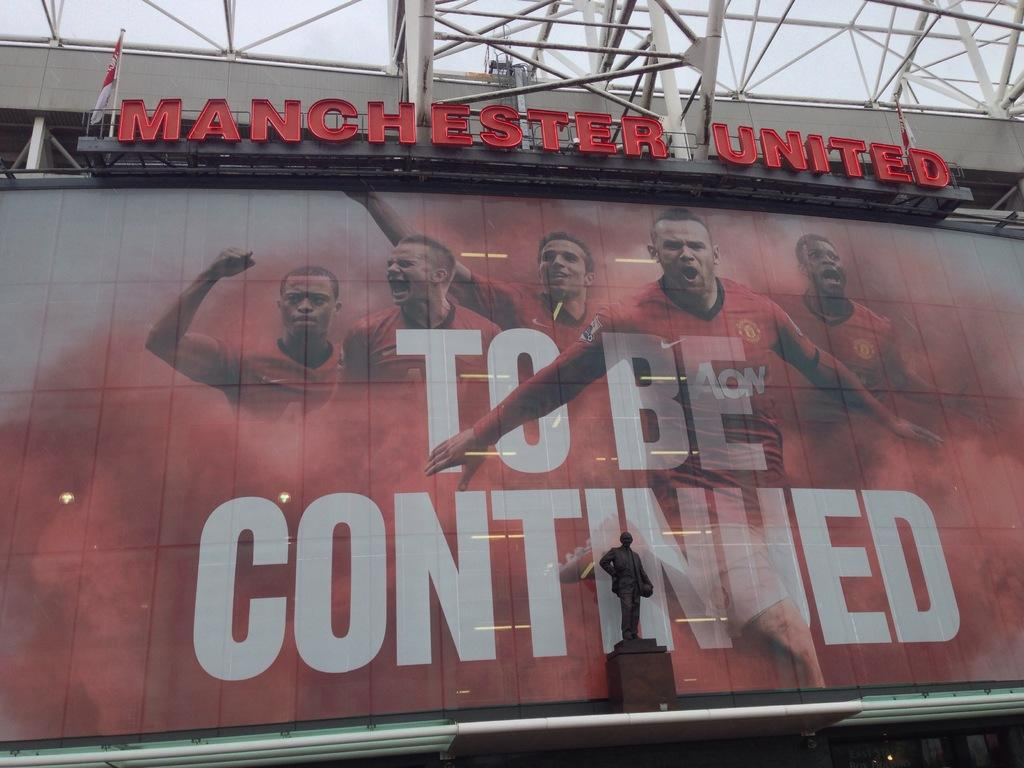Provide a one-sentence caption for the provided image. Signboard for Manchester United with the words TO BE CONTINUED displayed. 